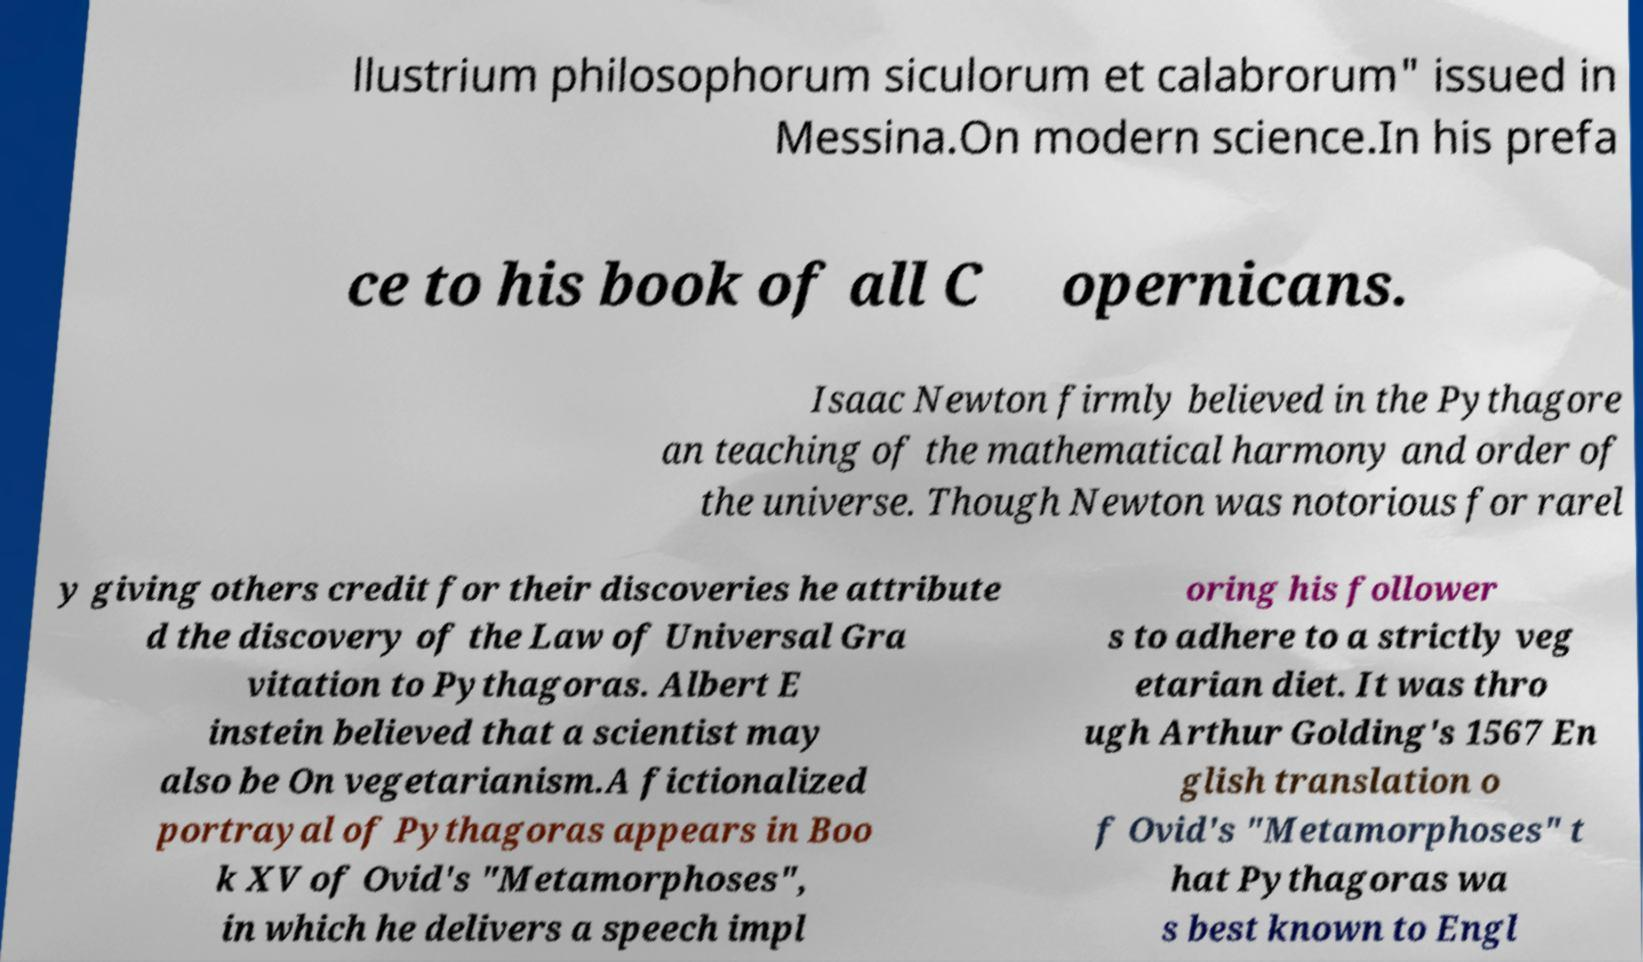For documentation purposes, I need the text within this image transcribed. Could you provide that? llustrium philosophorum siculorum et calabrorum" issued in Messina.On modern science.In his prefa ce to his book of all C opernicans. Isaac Newton firmly believed in the Pythagore an teaching of the mathematical harmony and order of the universe. Though Newton was notorious for rarel y giving others credit for their discoveries he attribute d the discovery of the Law of Universal Gra vitation to Pythagoras. Albert E instein believed that a scientist may also be On vegetarianism.A fictionalized portrayal of Pythagoras appears in Boo k XV of Ovid's "Metamorphoses", in which he delivers a speech impl oring his follower s to adhere to a strictly veg etarian diet. It was thro ugh Arthur Golding's 1567 En glish translation o f Ovid's "Metamorphoses" t hat Pythagoras wa s best known to Engl 